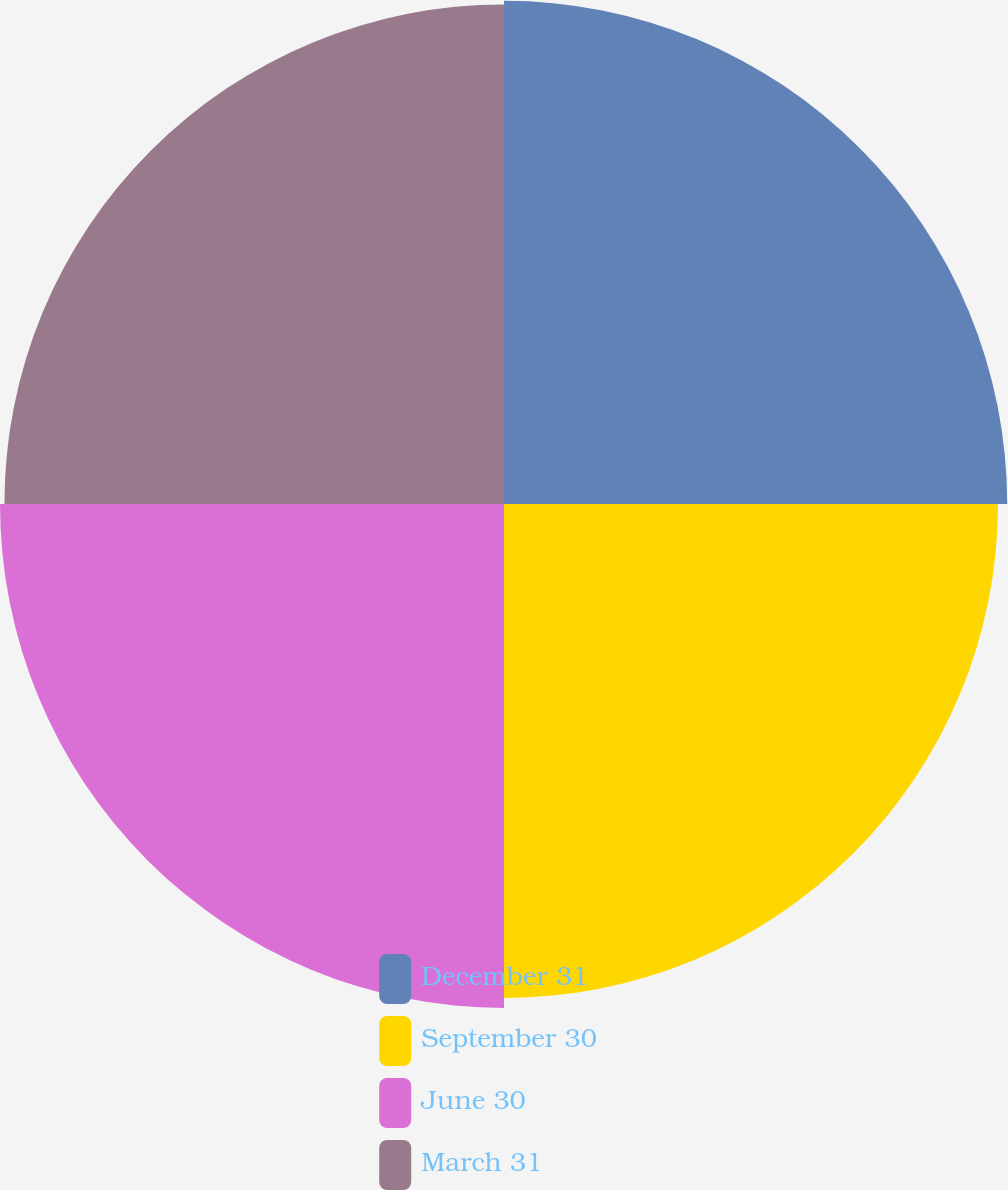Convert chart. <chart><loc_0><loc_0><loc_500><loc_500><pie_chart><fcel>December 31<fcel>September 30<fcel>June 30<fcel>March 31<nl><fcel>25.15%<fcel>24.69%<fcel>25.19%<fcel>24.97%<nl></chart> 